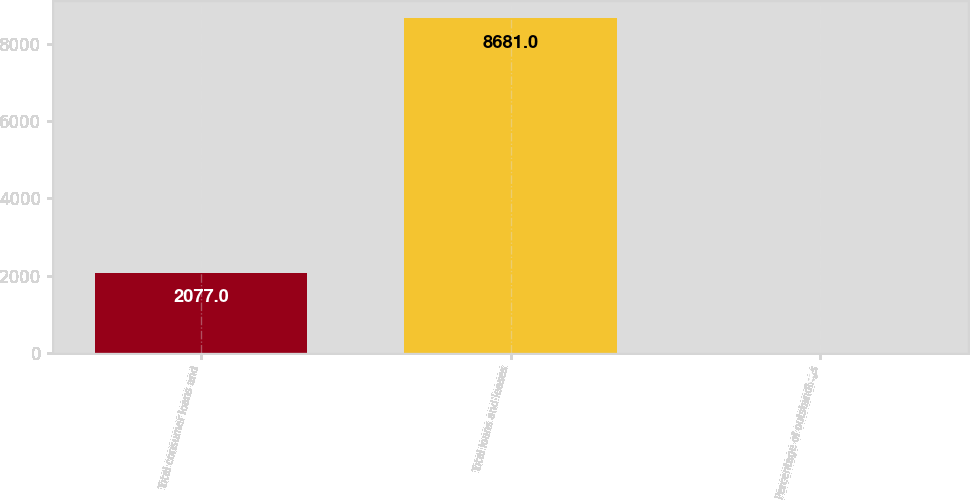<chart> <loc_0><loc_0><loc_500><loc_500><bar_chart><fcel>Total consumer loans and<fcel>Total loans and leases<fcel>Percentage of outstandings<nl><fcel>2077<fcel>8681<fcel>0.98<nl></chart> 